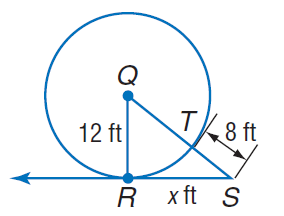Answer the mathemtical geometry problem and directly provide the correct option letter.
Question: Find x. Assume that segments that appear to be tangent are tangent.
Choices: A: 8 B: 12 C: 16 D: 20 C 